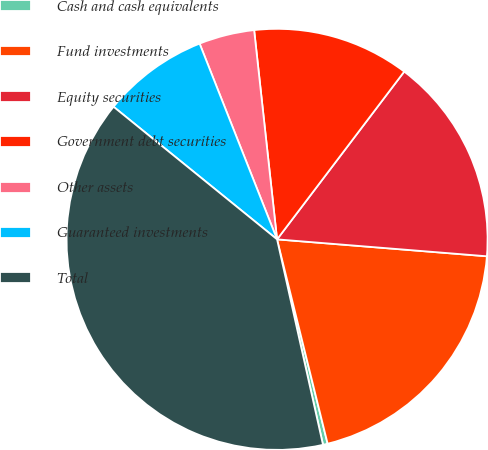Convert chart to OTSL. <chart><loc_0><loc_0><loc_500><loc_500><pie_chart><fcel>Cash and cash equivalents<fcel>Fund investments<fcel>Equity securities<fcel>Government debt securities<fcel>Other assets<fcel>Guaranteed investments<fcel>Total<nl><fcel>0.36%<fcel>19.86%<fcel>15.96%<fcel>12.06%<fcel>4.26%<fcel>8.16%<fcel>39.35%<nl></chart> 